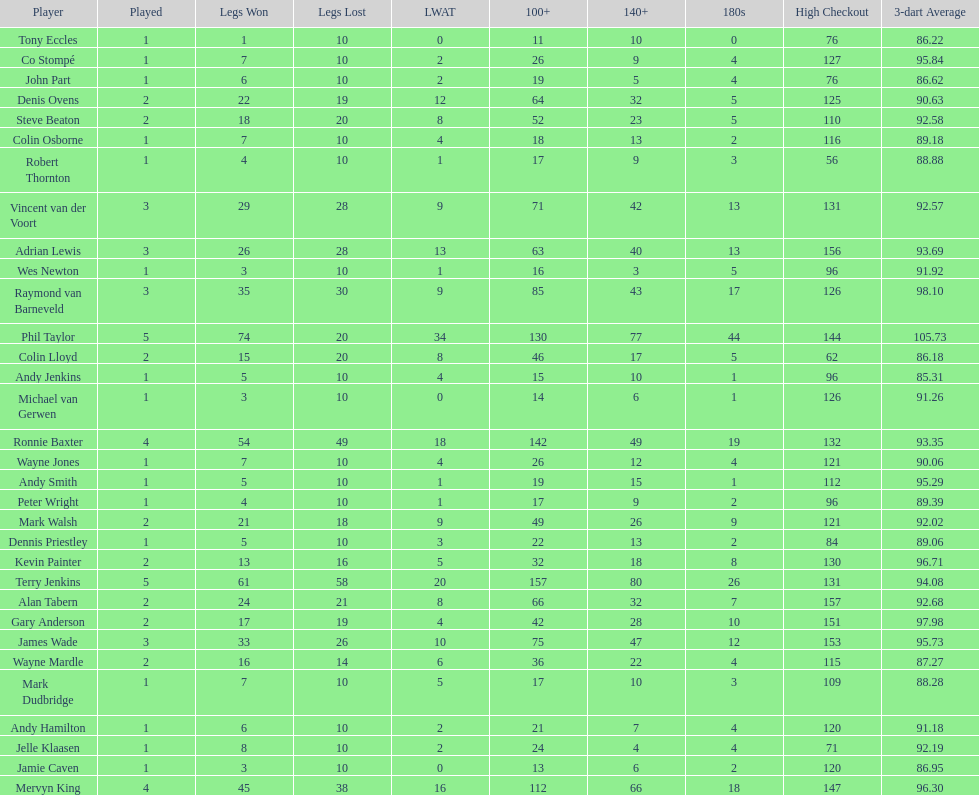What are the number of legs lost by james wade? 26. I'm looking to parse the entire table for insights. Could you assist me with that? {'header': ['Player', 'Played', 'Legs Won', 'Legs Lost', 'LWAT', '100+', '140+', '180s', 'High Checkout', '3-dart Average'], 'rows': [['Tony Eccles', '1', '1', '10', '0', '11', '10', '0', '76', '86.22'], ['Co Stompé', '1', '7', '10', '2', '26', '9', '4', '127', '95.84'], ['John Part', '1', '6', '10', '2', '19', '5', '4', '76', '86.62'], ['Denis Ovens', '2', '22', '19', '12', '64', '32', '5', '125', '90.63'], ['Steve Beaton', '2', '18', '20', '8', '52', '23', '5', '110', '92.58'], ['Colin Osborne', '1', '7', '10', '4', '18', '13', '2', '116', '89.18'], ['Robert Thornton', '1', '4', '10', '1', '17', '9', '3', '56', '88.88'], ['Vincent van der Voort', '3', '29', '28', '9', '71', '42', '13', '131', '92.57'], ['Adrian Lewis', '3', '26', '28', '13', '63', '40', '13', '156', '93.69'], ['Wes Newton', '1', '3', '10', '1', '16', '3', '5', '96', '91.92'], ['Raymond van Barneveld', '3', '35', '30', '9', '85', '43', '17', '126', '98.10'], ['Phil Taylor', '5', '74', '20', '34', '130', '77', '44', '144', '105.73'], ['Colin Lloyd', '2', '15', '20', '8', '46', '17', '5', '62', '86.18'], ['Andy Jenkins', '1', '5', '10', '4', '15', '10', '1', '96', '85.31'], ['Michael van Gerwen', '1', '3', '10', '0', '14', '6', '1', '126', '91.26'], ['Ronnie Baxter', '4', '54', '49', '18', '142', '49', '19', '132', '93.35'], ['Wayne Jones', '1', '7', '10', '4', '26', '12', '4', '121', '90.06'], ['Andy Smith', '1', '5', '10', '1', '19', '15', '1', '112', '95.29'], ['Peter Wright', '1', '4', '10', '1', '17', '9', '2', '96', '89.39'], ['Mark Walsh', '2', '21', '18', '9', '49', '26', '9', '121', '92.02'], ['Dennis Priestley', '1', '5', '10', '3', '22', '13', '2', '84', '89.06'], ['Kevin Painter', '2', '13', '16', '5', '32', '18', '8', '130', '96.71'], ['Terry Jenkins', '5', '61', '58', '20', '157', '80', '26', '131', '94.08'], ['Alan Tabern', '2', '24', '21', '8', '66', '32', '7', '157', '92.68'], ['Gary Anderson', '2', '17', '19', '4', '42', '28', '10', '151', '97.98'], ['James Wade', '3', '33', '26', '10', '75', '47', '12', '153', '95.73'], ['Wayne Mardle', '2', '16', '14', '6', '36', '22', '4', '115', '87.27'], ['Mark Dudbridge', '1', '7', '10', '5', '17', '10', '3', '109', '88.28'], ['Andy Hamilton', '1', '6', '10', '2', '21', '7', '4', '120', '91.18'], ['Jelle Klaasen', '1', '8', '10', '2', '24', '4', '4', '71', '92.19'], ['Jamie Caven', '1', '3', '10', '0', '13', '6', '2', '120', '86.95'], ['Mervyn King', '4', '45', '38', '16', '112', '66', '18', '147', '96.30']]} 